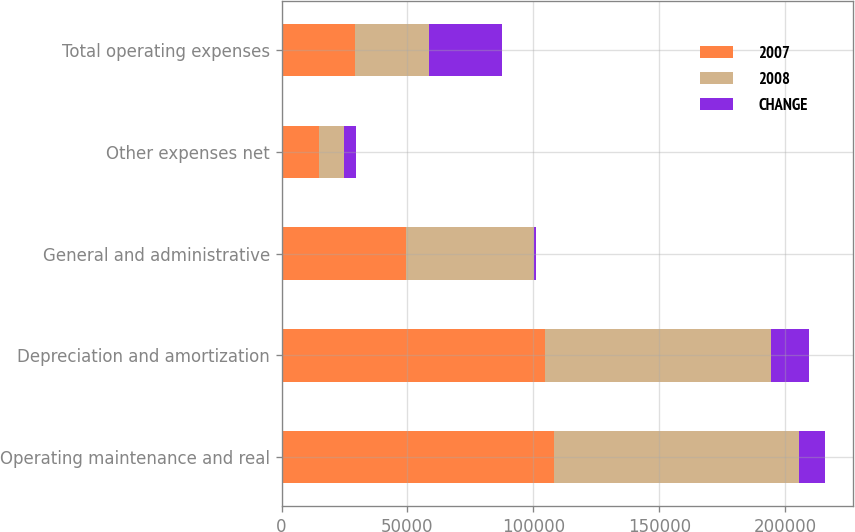Convert chart to OTSL. <chart><loc_0><loc_0><loc_500><loc_500><stacked_bar_chart><ecel><fcel>Operating maintenance and real<fcel>Depreciation and amortization<fcel>General and administrative<fcel>Other expenses net<fcel>Total operating expenses<nl><fcel>2007<fcel>108006<fcel>104739<fcel>49495<fcel>14824<fcel>29229<nl><fcel>2008<fcel>97635<fcel>89539<fcel>50580<fcel>10081<fcel>29229<nl><fcel>CHANGE<fcel>10371<fcel>15200<fcel>1085<fcel>4743<fcel>29229<nl></chart> 